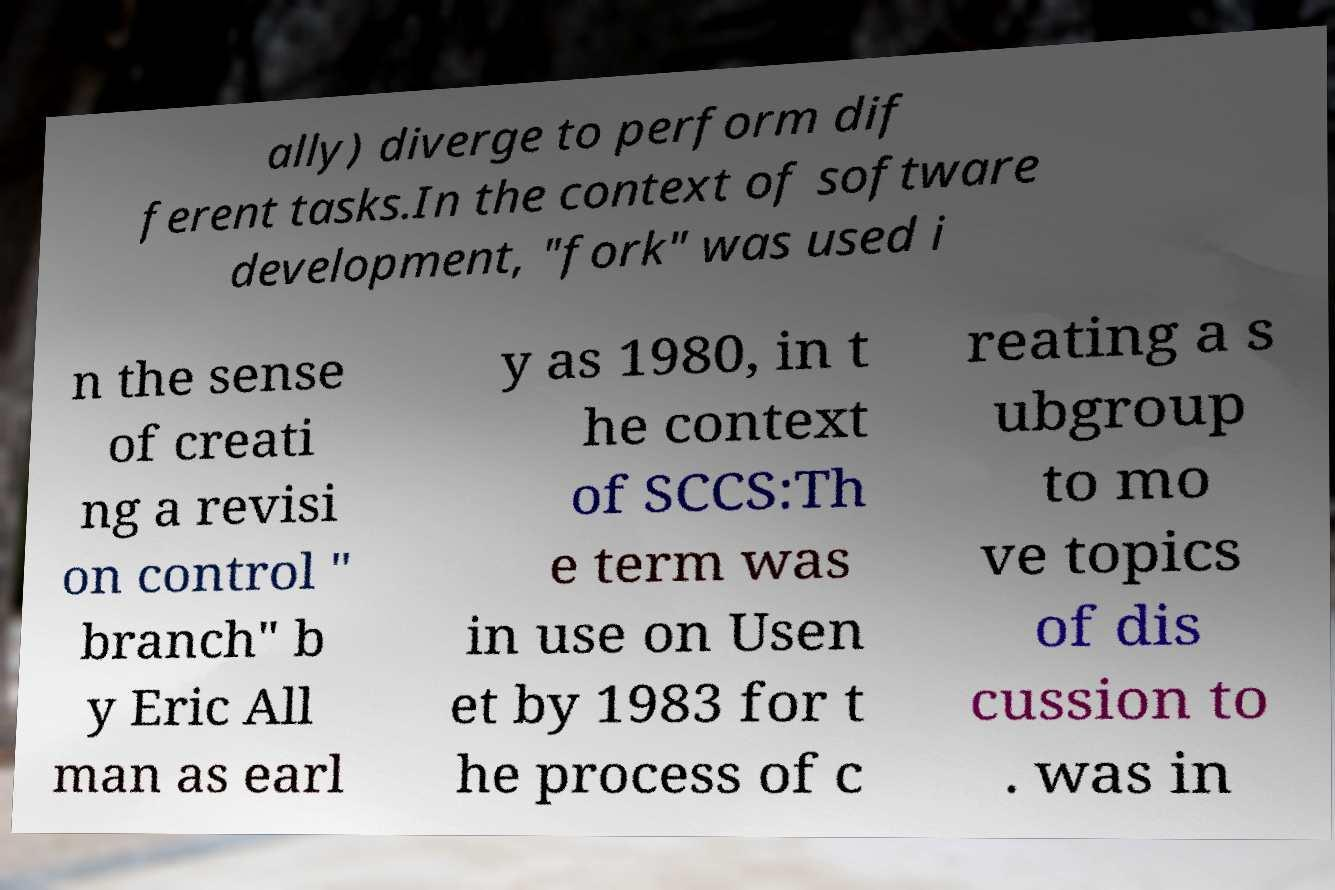Can you accurately transcribe the text from the provided image for me? ally) diverge to perform dif ferent tasks.In the context of software development, "fork" was used i n the sense of creati ng a revisi on control " branch" b y Eric All man as earl y as 1980, in t he context of SCCS:Th e term was in use on Usen et by 1983 for t he process of c reating a s ubgroup to mo ve topics of dis cussion to . was in 